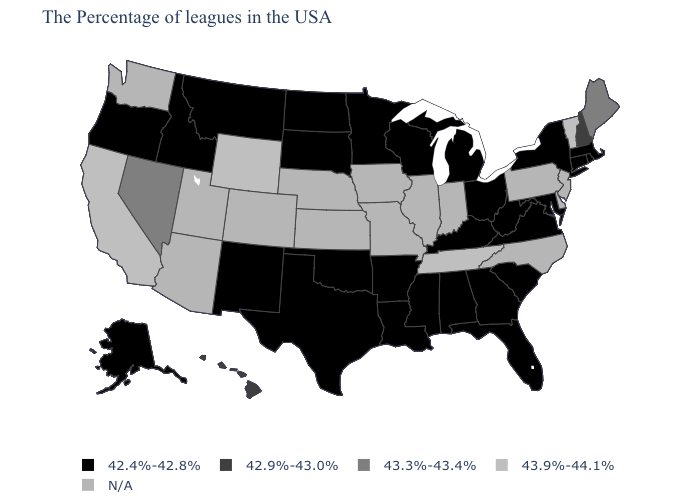What is the value of Louisiana?
Be succinct. 42.4%-42.8%. How many symbols are there in the legend?
Short answer required. 5. What is the lowest value in the MidWest?
Be succinct. 42.4%-42.8%. Name the states that have a value in the range 42.4%-42.8%?
Concise answer only. Massachusetts, Rhode Island, Connecticut, New York, Maryland, Virginia, South Carolina, West Virginia, Ohio, Florida, Georgia, Michigan, Kentucky, Alabama, Wisconsin, Mississippi, Louisiana, Arkansas, Minnesota, Oklahoma, Texas, South Dakota, North Dakota, New Mexico, Montana, Idaho, Oregon, Alaska. What is the value of Alabama?
Answer briefly. 42.4%-42.8%. What is the value of Illinois?
Short answer required. N/A. Does Wyoming have the highest value in the West?
Answer briefly. Yes. Name the states that have a value in the range 43.9%-44.1%?
Answer briefly. Vermont, Tennessee, Wyoming, California. Does the map have missing data?
Keep it brief. Yes. What is the value of North Dakota?
Concise answer only. 42.4%-42.8%. Does Tennessee have the highest value in the USA?
Answer briefly. Yes. What is the value of Connecticut?
Be succinct. 42.4%-42.8%. Name the states that have a value in the range 43.9%-44.1%?
Quick response, please. Vermont, Tennessee, Wyoming, California. Name the states that have a value in the range 43.9%-44.1%?
Be succinct. Vermont, Tennessee, Wyoming, California. 